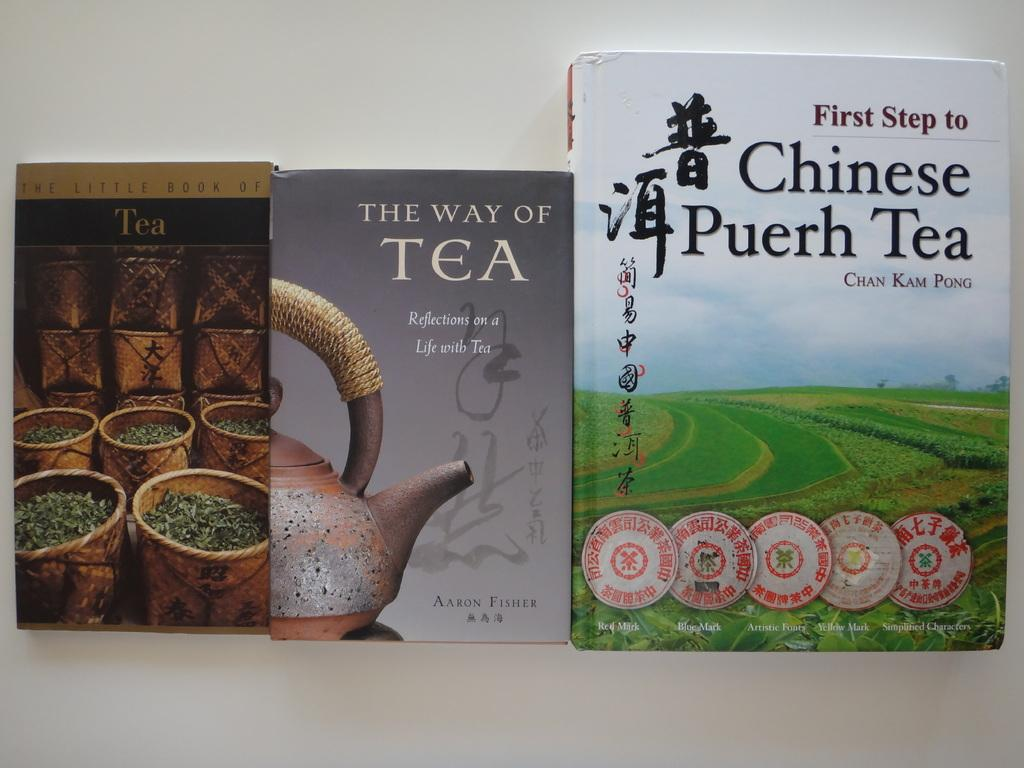Provide a one-sentence caption for the provided image. All three of the books pictured are about tea. 